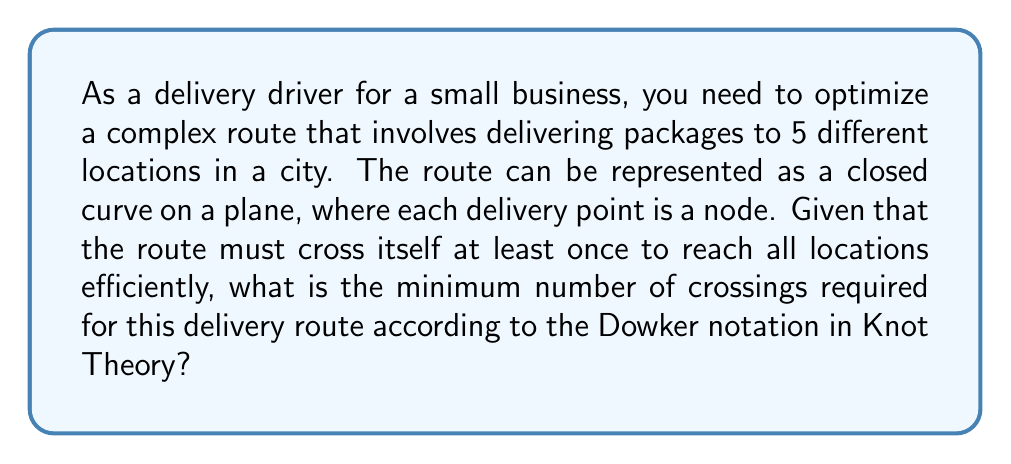Give your solution to this math problem. To solve this problem, we'll use concepts from Knot Theory, specifically the Dowker notation and the relationship between the number of crossings and the complexity of a knot.

Step 1: Understand the problem
We have a closed curve (the delivery route) with 5 nodes (delivery points) that must cross itself at least once.

Step 2: Apply Knot Theory concepts
In Knot Theory, a knot with the minimum number of crossings for a given complexity is called a minimal crossing number knot.

Step 3: Consider the simplest non-trivial knot
The simplest non-trivial knot is the trefoil knot, which has 3 crossings.

Step 4: Analyze the complexity of our route
With 5 delivery points, our route is more complex than a trefoil knot.

Step 5: Use the Dowker notation
The Dowker notation for a knot with n crossings is a sequence of 2n even integers. For our route to be more complex than a trefoil knot but still minimal, we need to consider the next level of complexity.

Step 6: Determine the minimal crossing number
The next level of complexity after the trefoil knot is a knot with 4 crossings, such as the figure-eight knot.

Step 7: Verify the solution
A 4-crossing knot can accommodate 5 delivery points while ensuring the route crosses itself at least once and remains efficient.

Therefore, the minimum number of crossings required for this complex delivery route is 4.
Answer: 4 